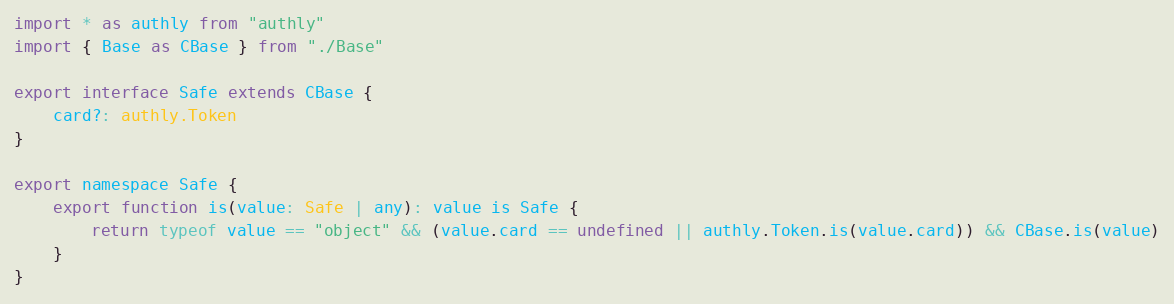Convert code to text. <code><loc_0><loc_0><loc_500><loc_500><_TypeScript_>import * as authly from "authly"
import { Base as CBase } from "./Base"

export interface Safe extends CBase {
	card?: authly.Token
}

export namespace Safe {
	export function is(value: Safe | any): value is Safe {
		return typeof value == "object" && (value.card == undefined || authly.Token.is(value.card)) && CBase.is(value)
	}
}
</code> 